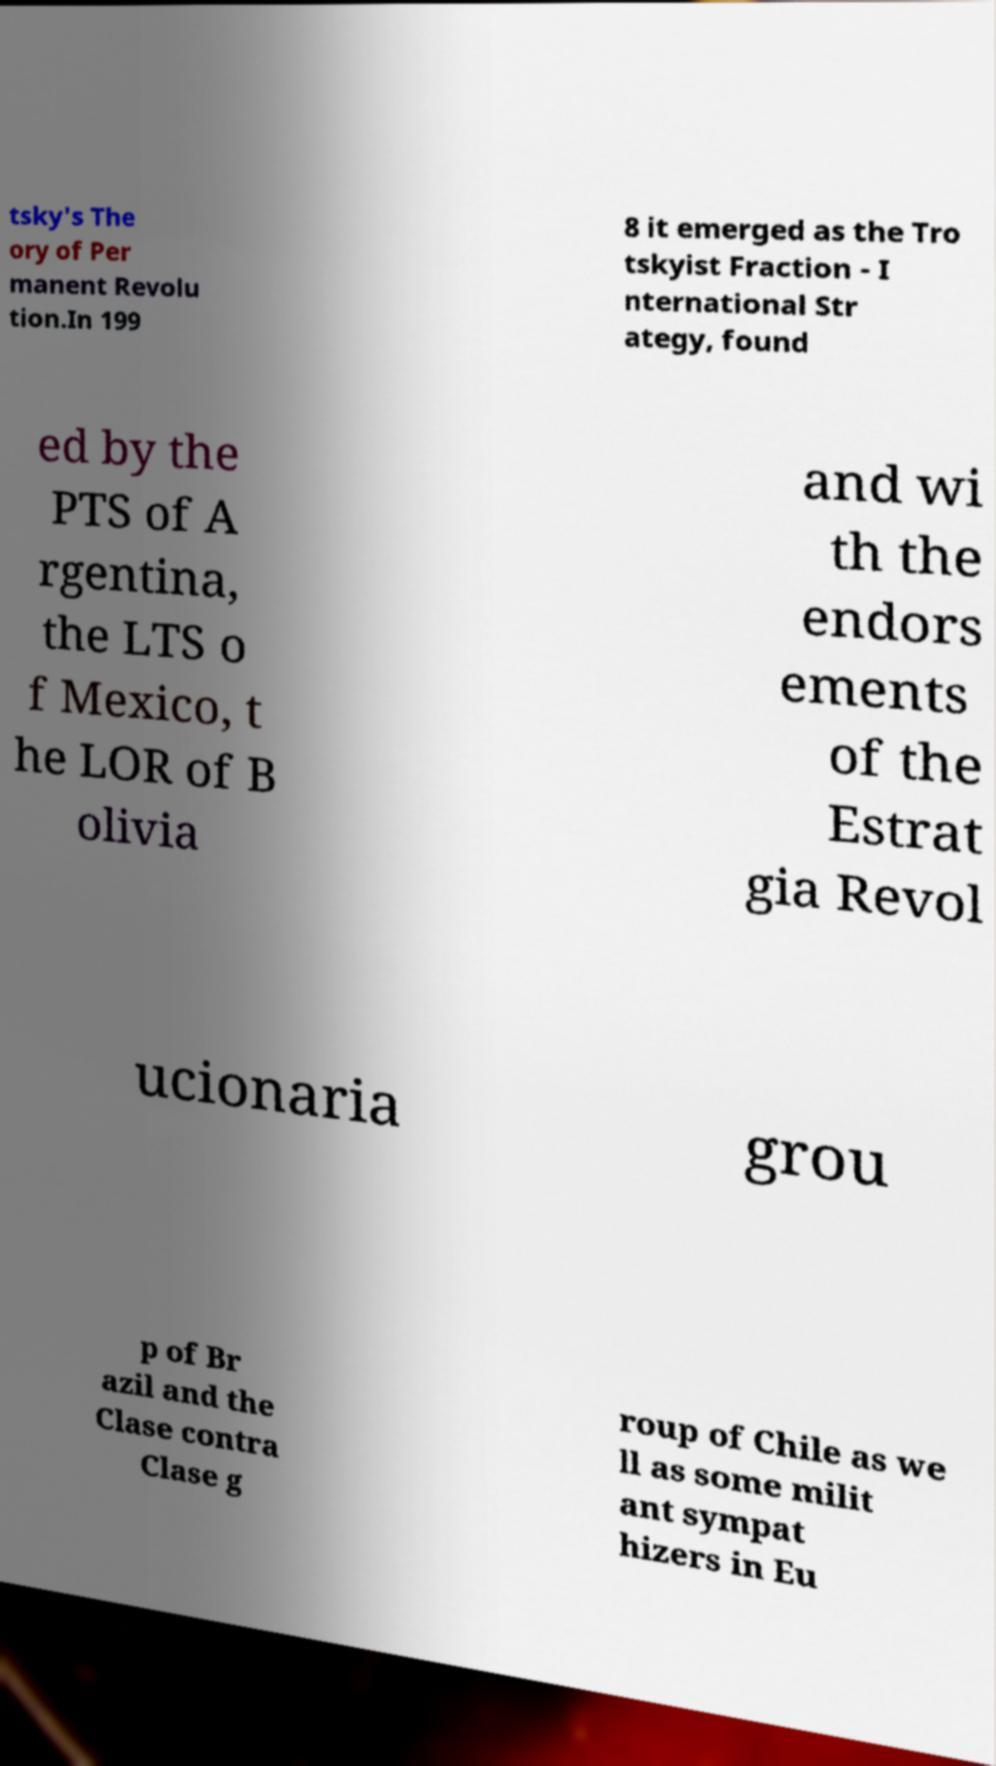Could you assist in decoding the text presented in this image and type it out clearly? tsky's The ory of Per manent Revolu tion.In 199 8 it emerged as the Tro tskyist Fraction - I nternational Str ategy, found ed by the PTS of A rgentina, the LTS o f Mexico, t he LOR of B olivia and wi th the endors ements of the Estrat gia Revol ucionaria grou p of Br azil and the Clase contra Clase g roup of Chile as we ll as some milit ant sympat hizers in Eu 